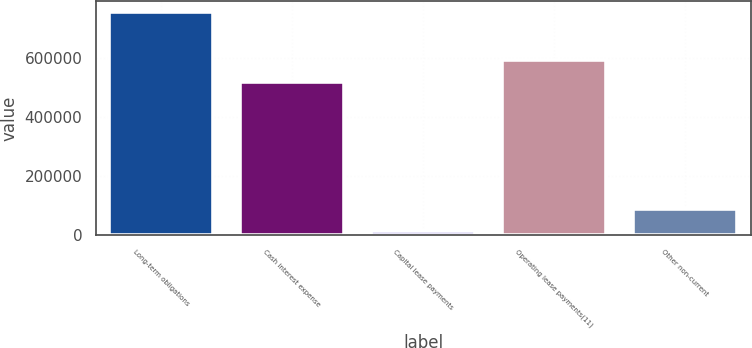<chart> <loc_0><loc_0><loc_500><loc_500><bar_chart><fcel>Long-term obligations<fcel>Cash interest expense<fcel>Capital lease payments<fcel>Operating lease payments(11)<fcel>Other non-current<nl><fcel>753045<fcel>517000<fcel>14049<fcel>590900<fcel>87948.6<nl></chart> 